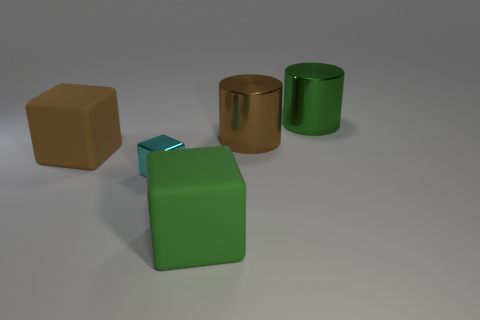Are there an equal number of big brown shiny objects that are to the left of the green cube and metal cylinders right of the large green metal object?
Your response must be concise. Yes. What number of objects are brown cubes or large matte blocks on the left side of the small cyan metallic cube?
Provide a short and direct response. 1. There is a metallic thing that is both on the left side of the green metallic object and behind the brown block; what is its shape?
Ensure brevity in your answer.  Cylinder. What is the big cylinder that is behind the big metal cylinder that is in front of the green metal cylinder made of?
Provide a succinct answer. Metal. Do the green thing that is in front of the tiny shiny cube and the large brown cylinder have the same material?
Give a very brief answer. No. How big is the green thing behind the large green rubber thing?
Make the answer very short. Large. Are there any big cylinders that are behind the brown object to the right of the brown rubber block?
Your answer should be compact. Yes. Is the color of the big thing in front of the cyan shiny cube the same as the big cylinder behind the brown metallic object?
Make the answer very short. Yes. The shiny block is what color?
Offer a terse response. Cyan. Is there any other thing that is the same color as the small metallic cube?
Your response must be concise. No. 